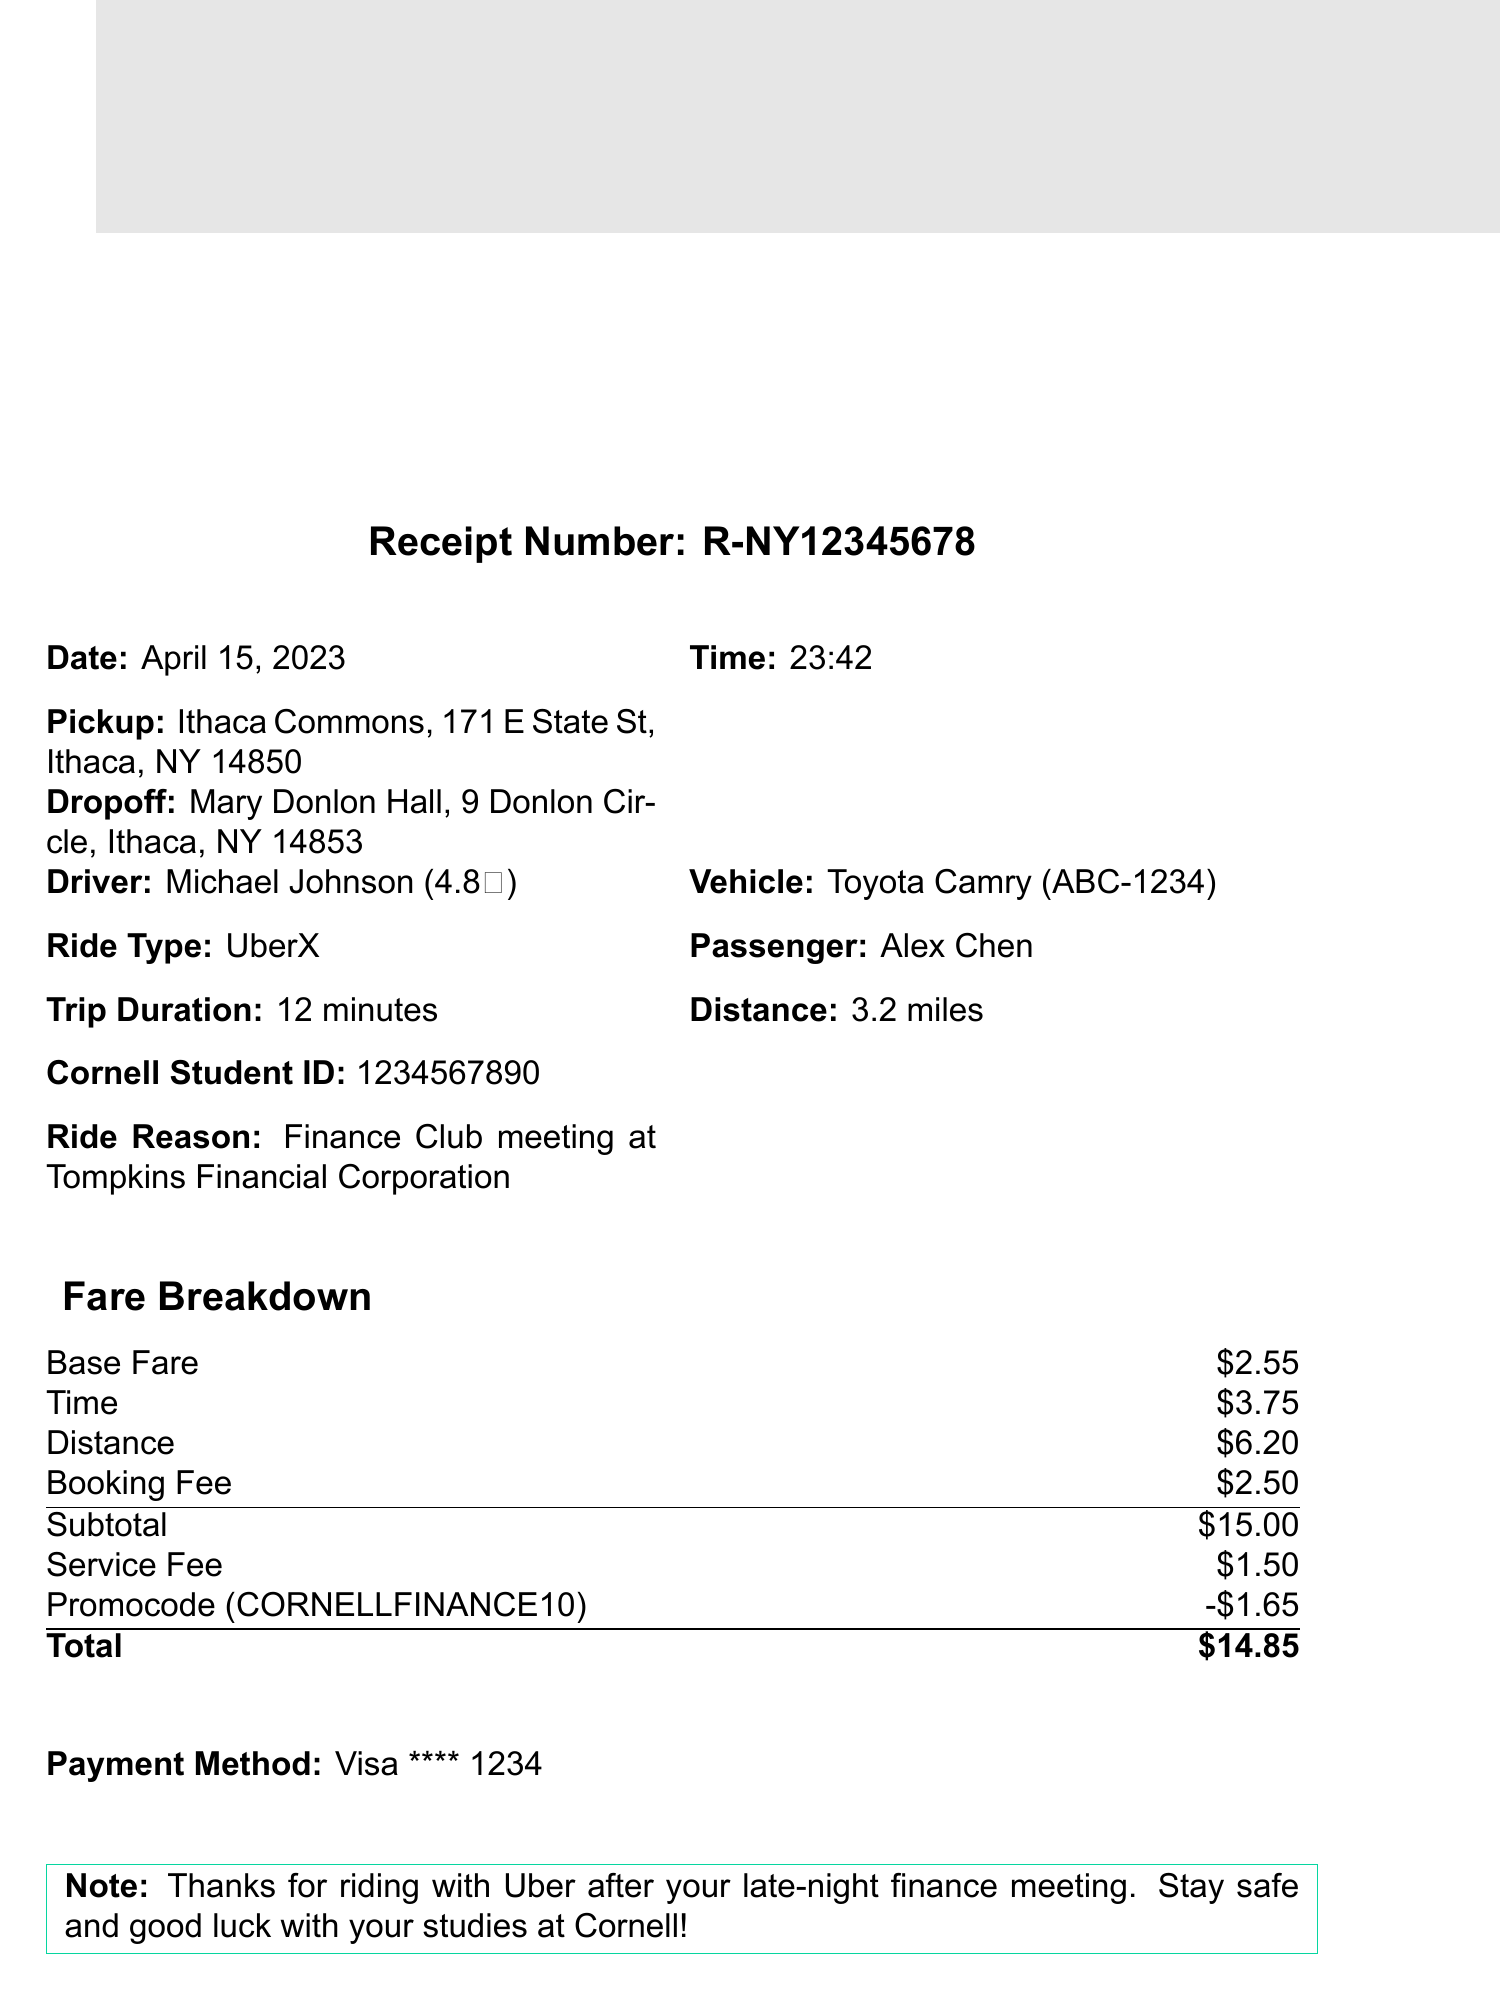What is the receipt number? The receipt number is a unique identifier for the transaction listed in the document.
Answer: R-NY12345678 What date was the ride? The date specifies when the ride took place and can be found in the document.
Answer: April 15, 2023 Who was the driver? The driver's name is mentioned in the document and helps identify them for the ride.
Answer: Michael Johnson What was the total fare? The total fare is the final amount charged for the ride after all calculations.
Answer: $14.85 What vehicle type was used? The type of vehicle provides information on the kind of ride service used.
Answer: Toyota Camry How long did the trip take? The trip duration indicates how long the ride lasted, which is mentioned in the document.
Answer: 12 minutes What was the ride reason? The ride reason explains the purpose of the trip as per the document’s details.
Answer: Finance Club meeting at Tompkins Financial Corporation Was a promocode applied? The promocode shows if there was a discount applied to the fare during the ride.
Answer: CORNELLFINANCE10 What was the discount amount? The discount amount reveals how much was deducted from the subtotal due to the promocode.
Answer: $1.65 